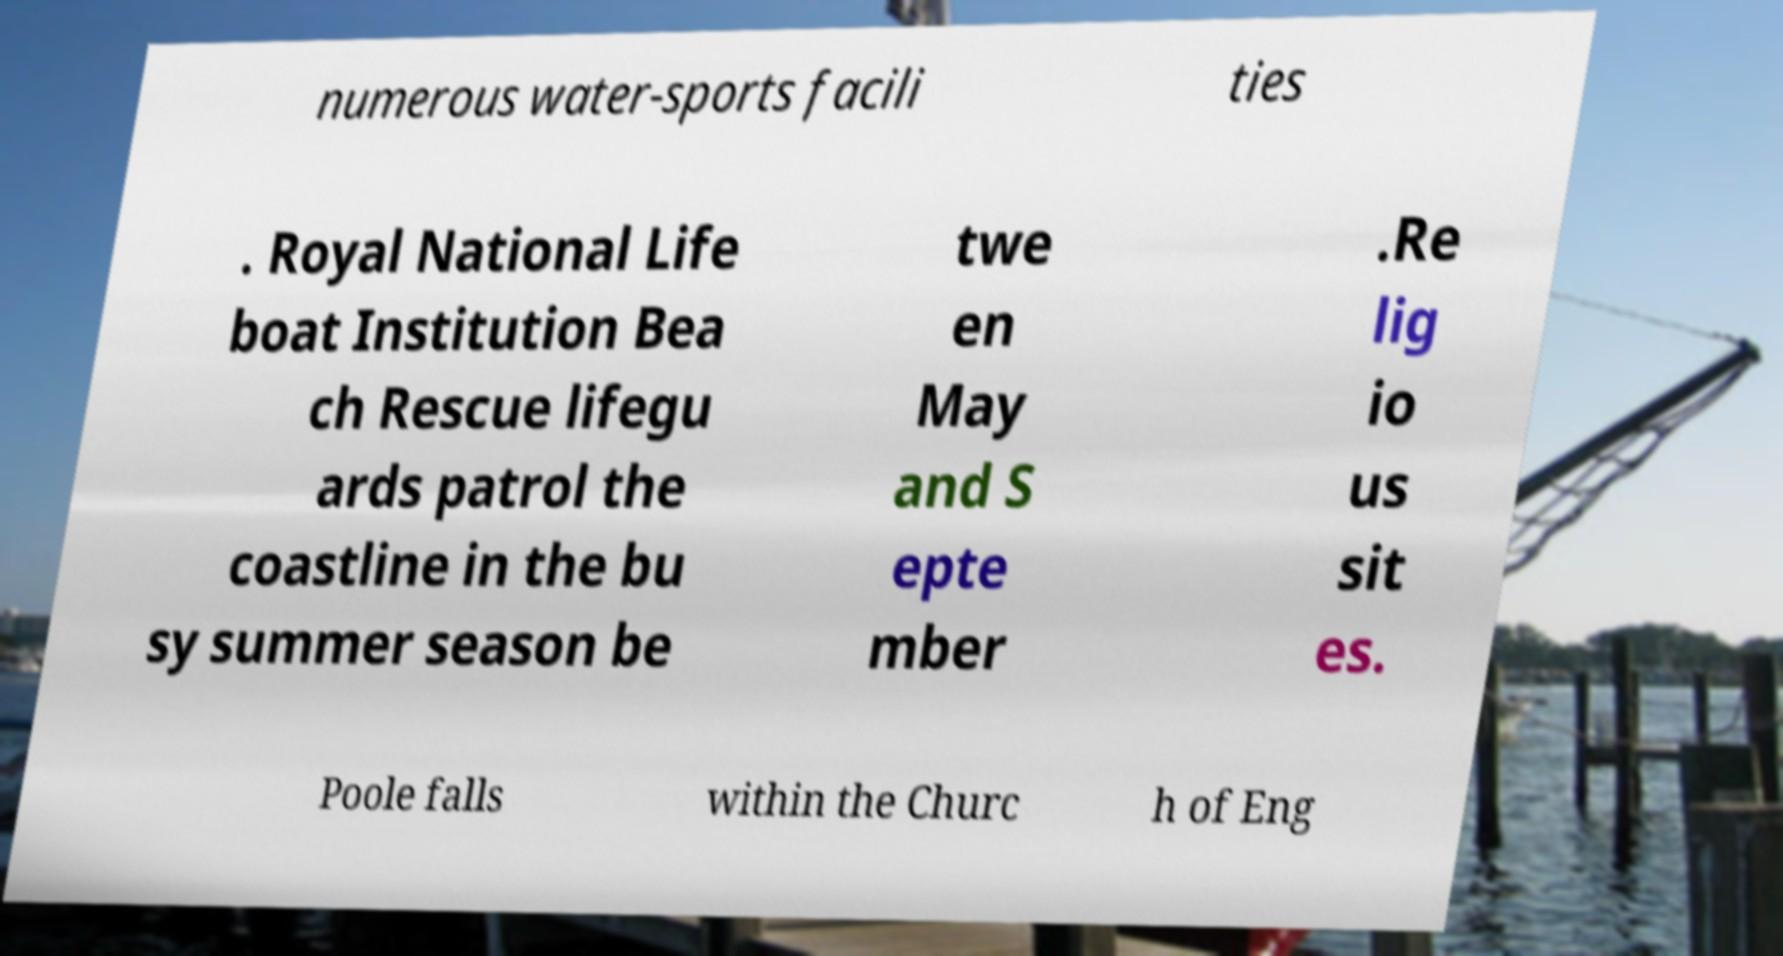I need the written content from this picture converted into text. Can you do that? numerous water-sports facili ties . Royal National Life boat Institution Bea ch Rescue lifegu ards patrol the coastline in the bu sy summer season be twe en May and S epte mber .Re lig io us sit es. Poole falls within the Churc h of Eng 